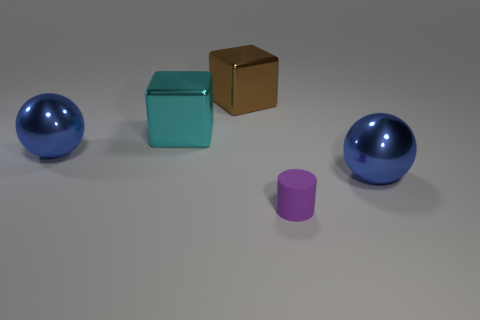Subtract all brown blocks. How many blocks are left? 1 Add 1 metal cubes. How many objects exist? 6 Subtract 1 blue balls. How many objects are left? 4 Subtract all cylinders. How many objects are left? 4 Subtract all purple cubes. Subtract all yellow cylinders. How many cubes are left? 2 Subtract all blue cylinders. How many brown blocks are left? 1 Subtract all balls. Subtract all big cyan shiny objects. How many objects are left? 2 Add 5 tiny purple cylinders. How many tiny purple cylinders are left? 6 Add 3 large cyan cubes. How many large cyan cubes exist? 4 